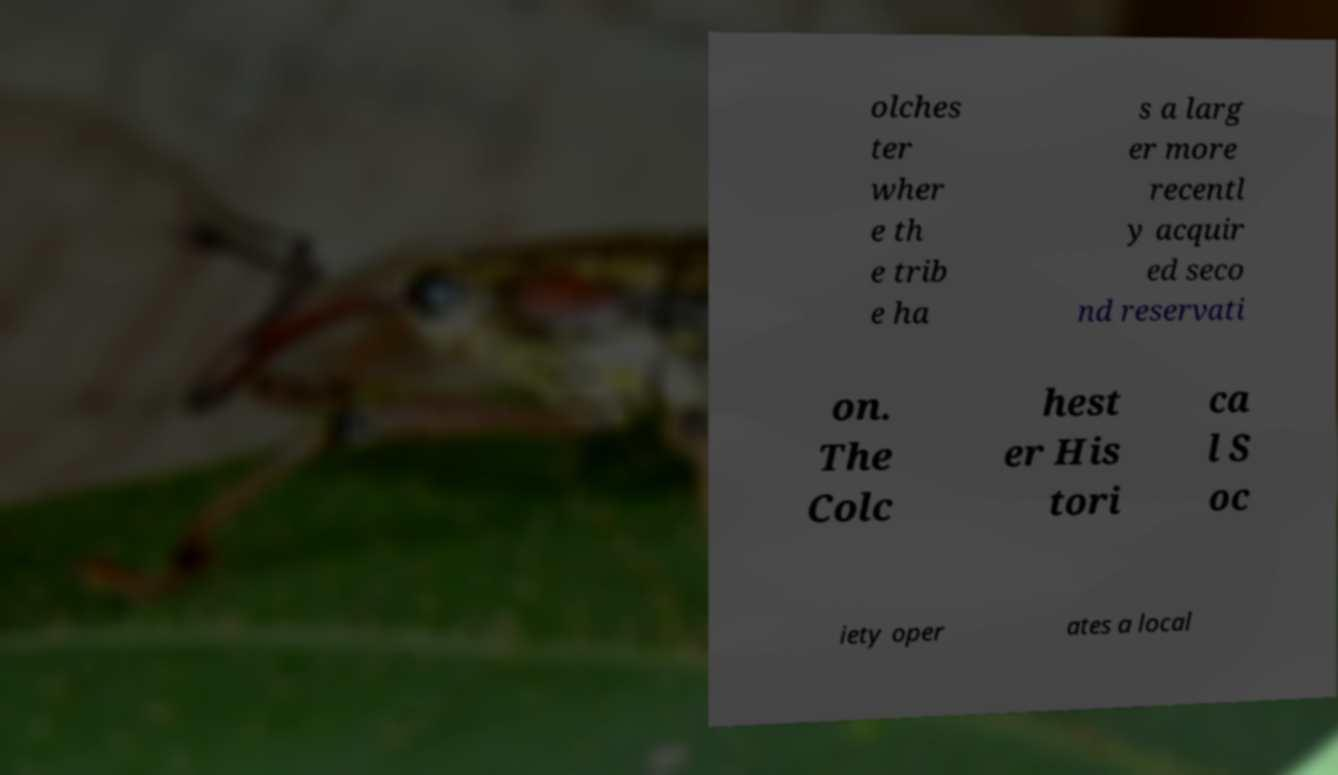What messages or text are displayed in this image? I need them in a readable, typed format. olches ter wher e th e trib e ha s a larg er more recentl y acquir ed seco nd reservati on. The Colc hest er His tori ca l S oc iety oper ates a local 